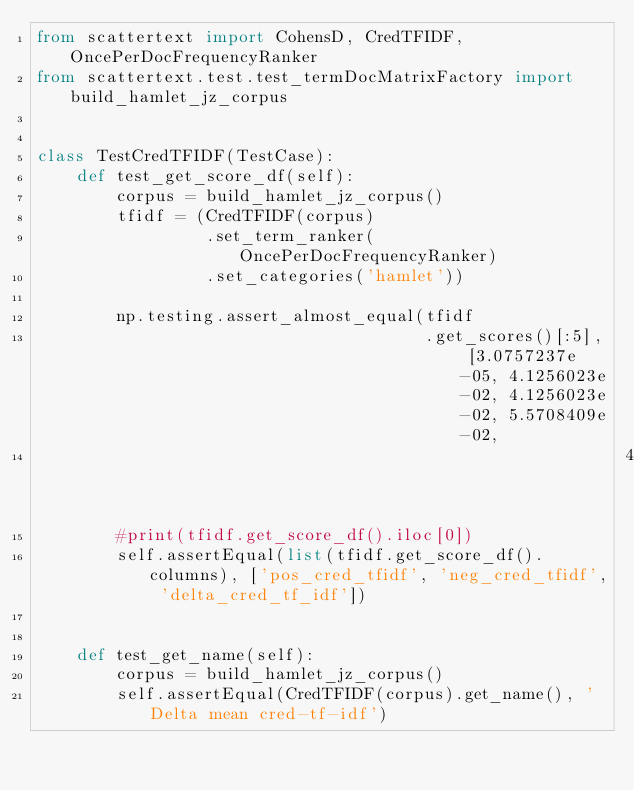<code> <loc_0><loc_0><loc_500><loc_500><_Python_>from scattertext import CohensD, CredTFIDF, OncePerDocFrequencyRanker
from scattertext.test.test_termDocMatrixFactory import build_hamlet_jz_corpus


class TestCredTFIDF(TestCase):
    def test_get_score_df(self):
        corpus = build_hamlet_jz_corpus()
        tfidf = (CredTFIDF(corpus)
                 .set_term_ranker(OncePerDocFrequencyRanker)
                 .set_categories('hamlet'))

        np.testing.assert_almost_equal(tfidf
                                       .get_scores()[:5], [3.0757237e-05, 4.1256023e-02, 4.1256023e-02, 5.5708409e-02,
                                                           4.1256023e-02])
        #print(tfidf.get_score_df().iloc[0])
        self.assertEqual(list(tfidf.get_score_df().columns), ['pos_cred_tfidf', 'neg_cred_tfidf', 'delta_cred_tf_idf'])


    def test_get_name(self):
        corpus = build_hamlet_jz_corpus()
        self.assertEqual(CredTFIDF(corpus).get_name(), 'Delta mean cred-tf-idf')
</code> 